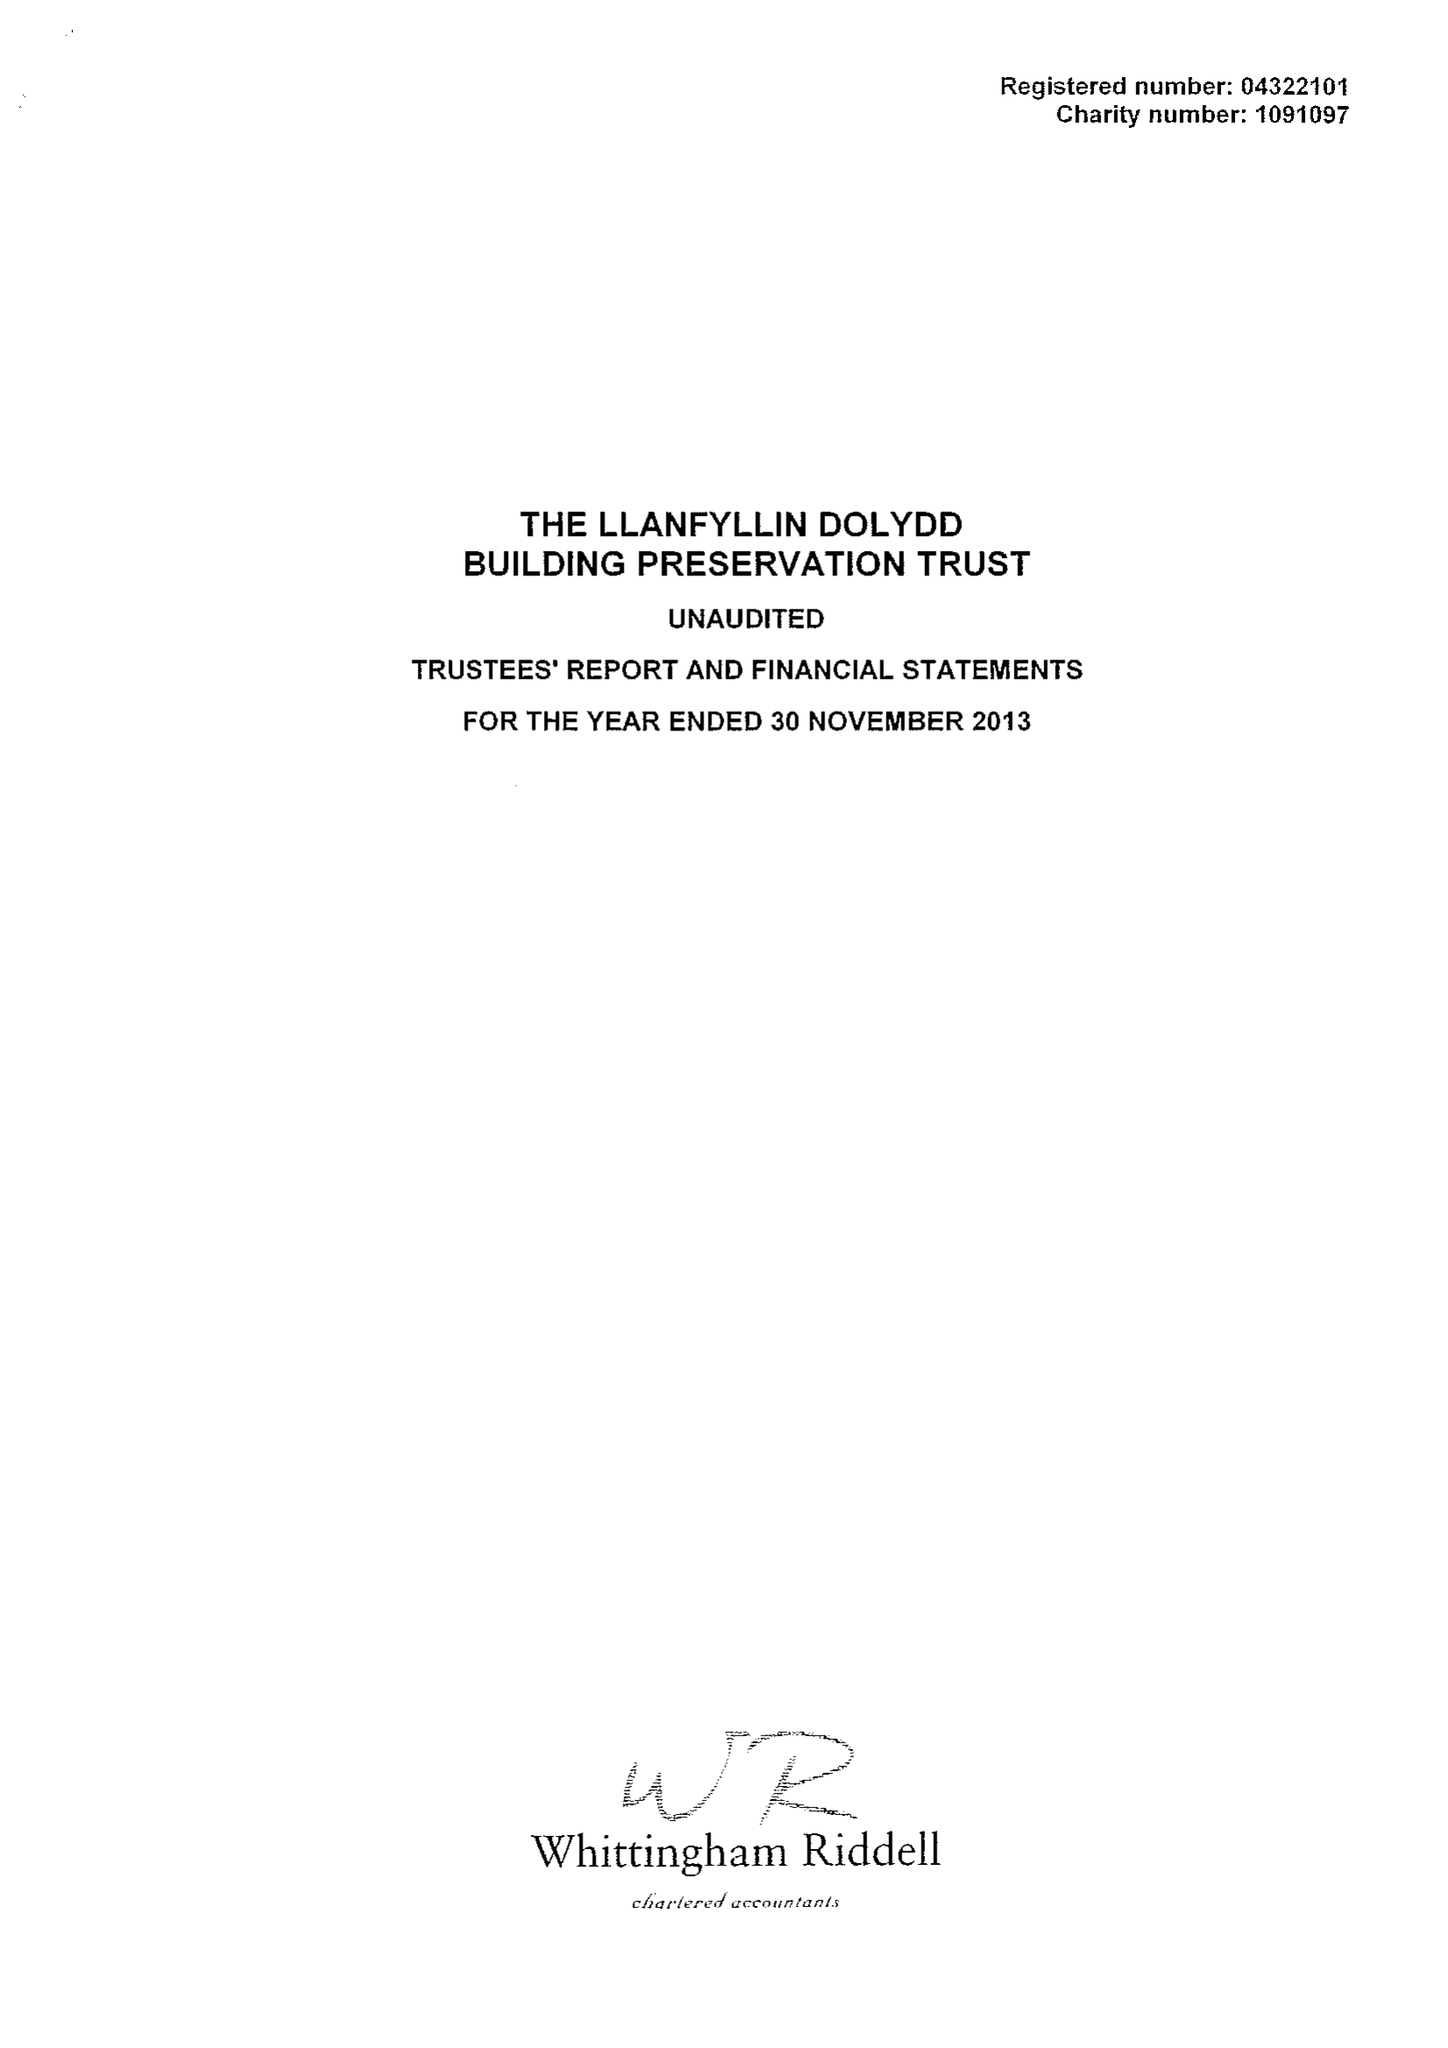What is the value for the address__street_line?
Answer the question using a single word or phrase. None 